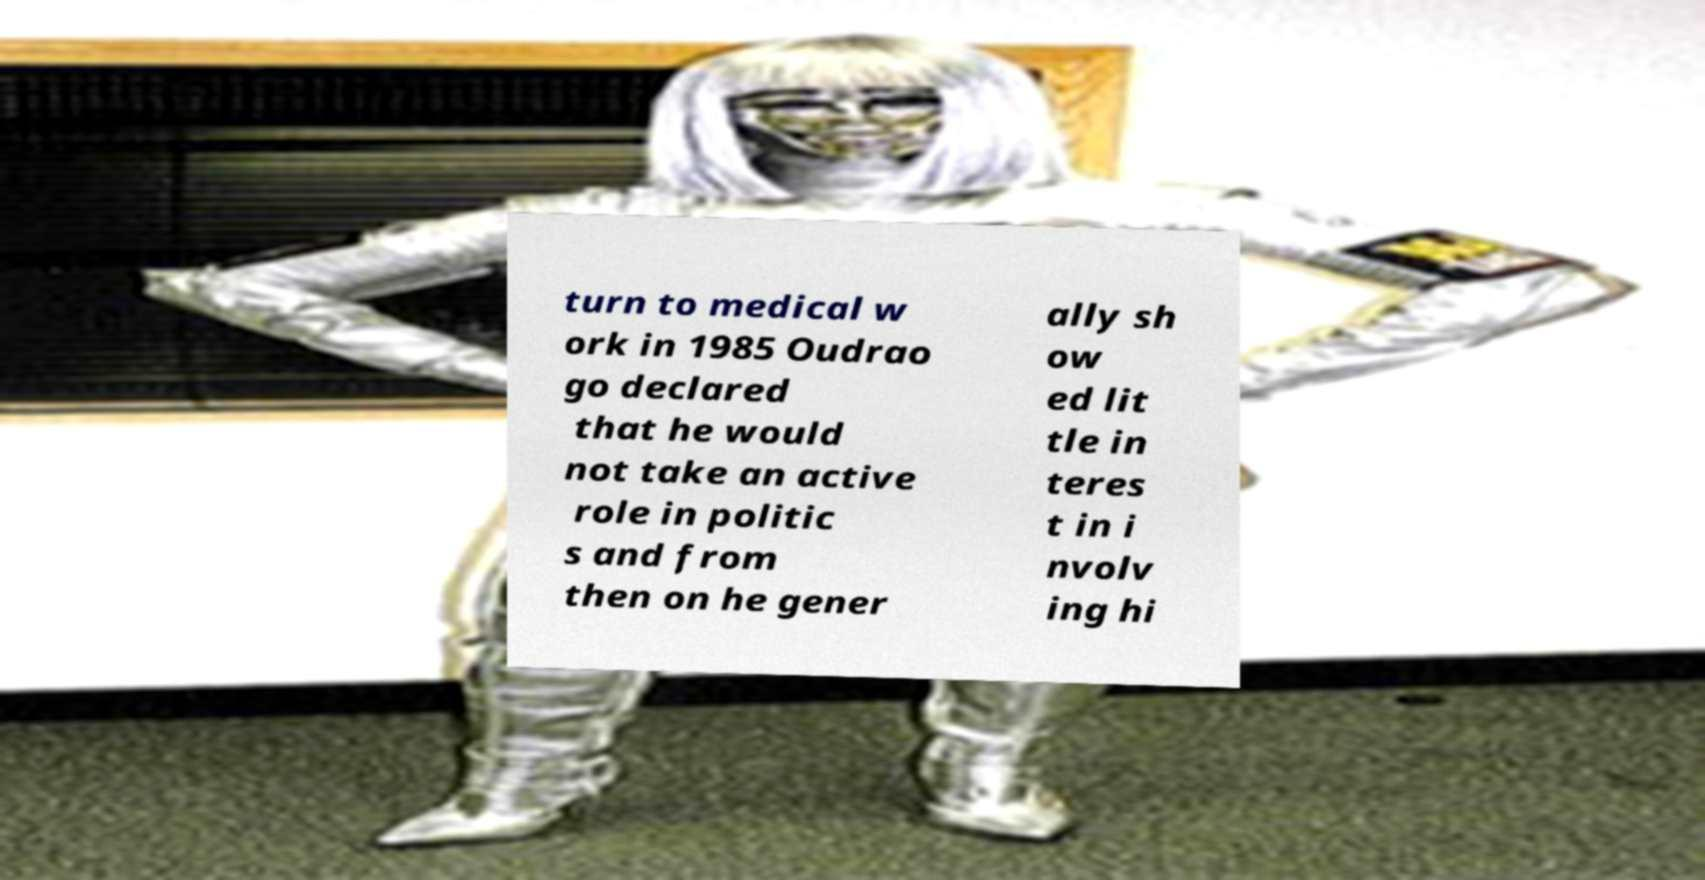For documentation purposes, I need the text within this image transcribed. Could you provide that? turn to medical w ork in 1985 Oudrao go declared that he would not take an active role in politic s and from then on he gener ally sh ow ed lit tle in teres t in i nvolv ing hi 